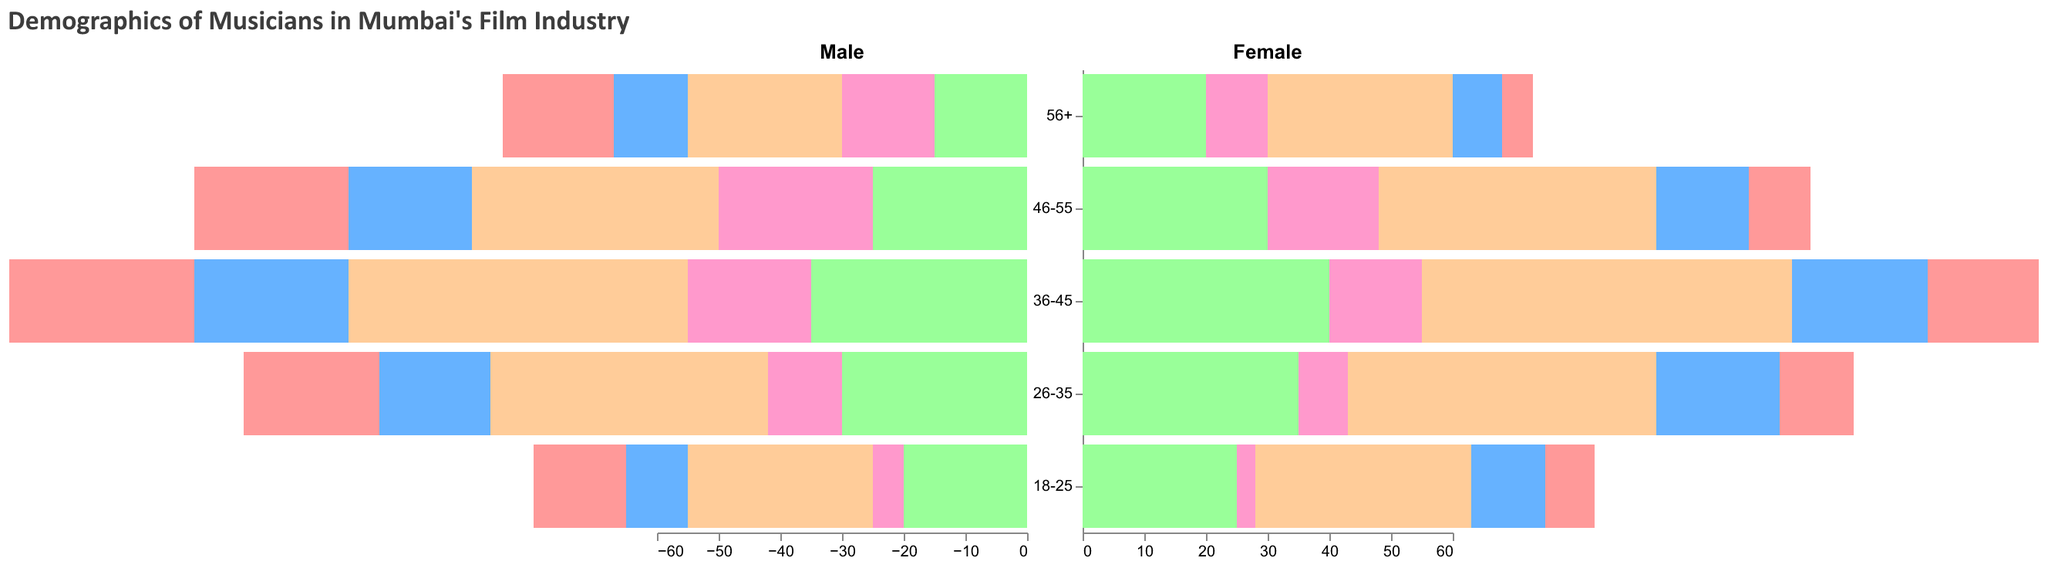What is the title of the figure? The title is located at the top of the figure and usually provides an overview of the information presented in the plot.
Answer: Demographics of Musicians in Mumbai's Film Industry Which instrument category has the highest number of female musicians in the 36-45 age group? Observing the female side (right side) of the population pyramid for the 36-45 age group and comparing the heights of the bars, Playback Singer stands out as the tallest.
Answer: Playback Singer What is the total number of male Tabla players in the 46-55 age group? Look at the male section (left side) of the plot, find the Tabla bar for the 46-55 age group, and count the number written there.
Answer: 25 Compare the number of male and female Sitar players in the 26-35 age group. Which gender has more musicians, and by how much? Find the number of male and female Sitar players in the 26-35 age group by looking at the heights of the bars on the respective sides. Subtract the smaller number from the larger one to find the difference.
Answer: Female, by 2 Which age group has the least number of female Harmonium players? On the female half of the plot (right side), compare the Harmonium bars for all age groups and identify the smallest bar.
Answer: 56+ What is the age group with the highest number of male Playback Singers? On the male side (left side) of the population pyramid, compare the heights of the Playback Singer bars across different age groups to find the tallest one.
Answer: 36-45 Which instrument has more male musicians overall in the figure, Tabla or Music Director? Sum up the number of male musicians across all age groups for both Tabla and Music Director and compare the two totals.
Answer: Tabla Are there more female musicians aged 18-25 playing Harmonium or Sitar? On the female side (right side) of the pyramid, compare the height of the bars for Harmonium and Sitar in the 18-25 age group.
Answer: Harmonium How many male and female musicians are there in total aged 56 and above? Sum the numbers of male and female musicians for each instrument in the 56+ age group.
Answer: 85 What is the most common instrument played by females aged 26-35? On the female half of the plot, identify the instrument bar with the highest count in the 26-35 age group.
Answer: Playback Singer 